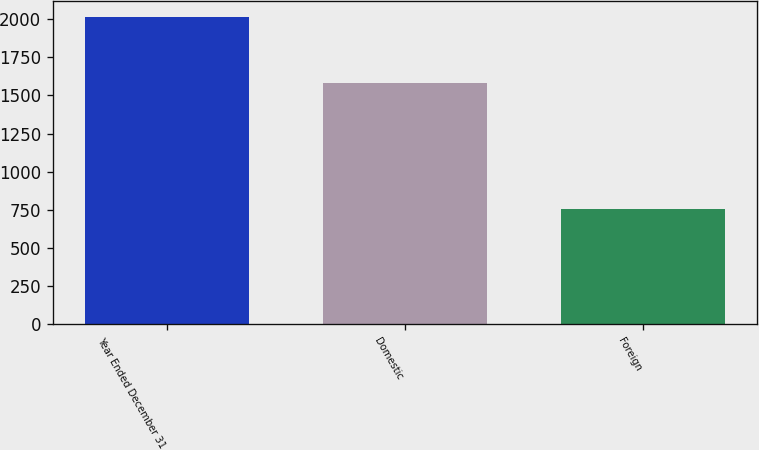Convert chart to OTSL. <chart><loc_0><loc_0><loc_500><loc_500><bar_chart><fcel>Year Ended December 31<fcel>Domestic<fcel>Foreign<nl><fcel>2015<fcel>1581.6<fcel>755.5<nl></chart> 